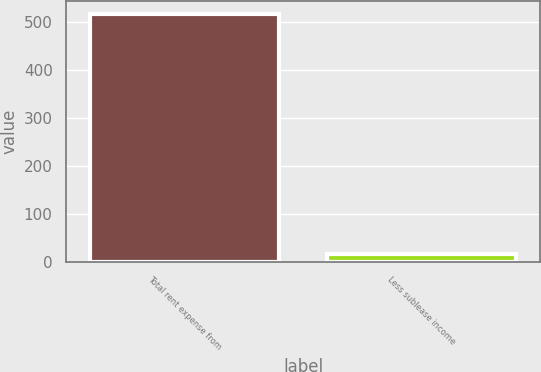Convert chart to OTSL. <chart><loc_0><loc_0><loc_500><loc_500><bar_chart><fcel>Total rent expense from<fcel>Less sublease income<nl><fcel>517<fcel>16<nl></chart> 